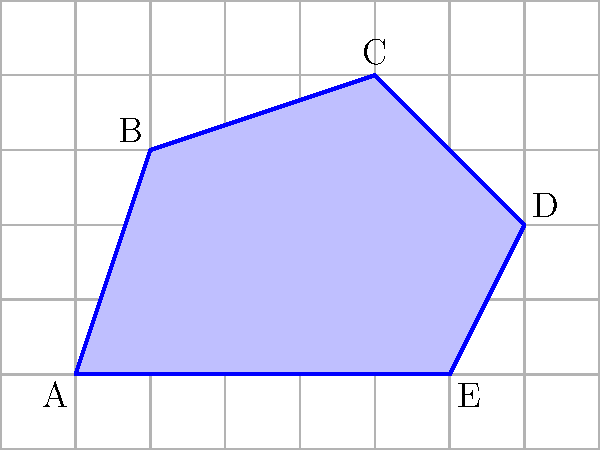As a content moderation team leader, you're analyzing user-generated content that includes irregular shapes. To accurately assess the size of these shapes, you need to calculate their areas. Given the irregular polygon ABCDE overlaid on a grid where each square represents 1 square unit, estimate its area to the nearest whole number. How would you approach this problem to ensure consistency in your team's content evaluation process? To estimate the area of the irregular polygon ABCDE, we can use the following approach:

1. Count the full squares inside the polygon:
   There are approximately 13 full squares within the shape.

2. Count the partial squares:
   There are about 14 partial squares along the edges of the polygon.

3. Estimate the area of partial squares:
   Assume that, on average, each partial square contributes half a square unit to the total area.
   Estimated area of partial squares = $14 \times 0.5 = 7$ square units

4. Calculate the total estimated area:
   Total area = Full squares + Estimated partial squares
               = $13 + 7 = 20$ square units

5. Round to the nearest whole number:
   The area is already a whole number, so no rounding is necessary.

This method provides a consistent approach for the content moderation team to estimate areas of irregular shapes in user-generated content, ensuring uniformity in evaluations across the team.
Answer: 20 square units 